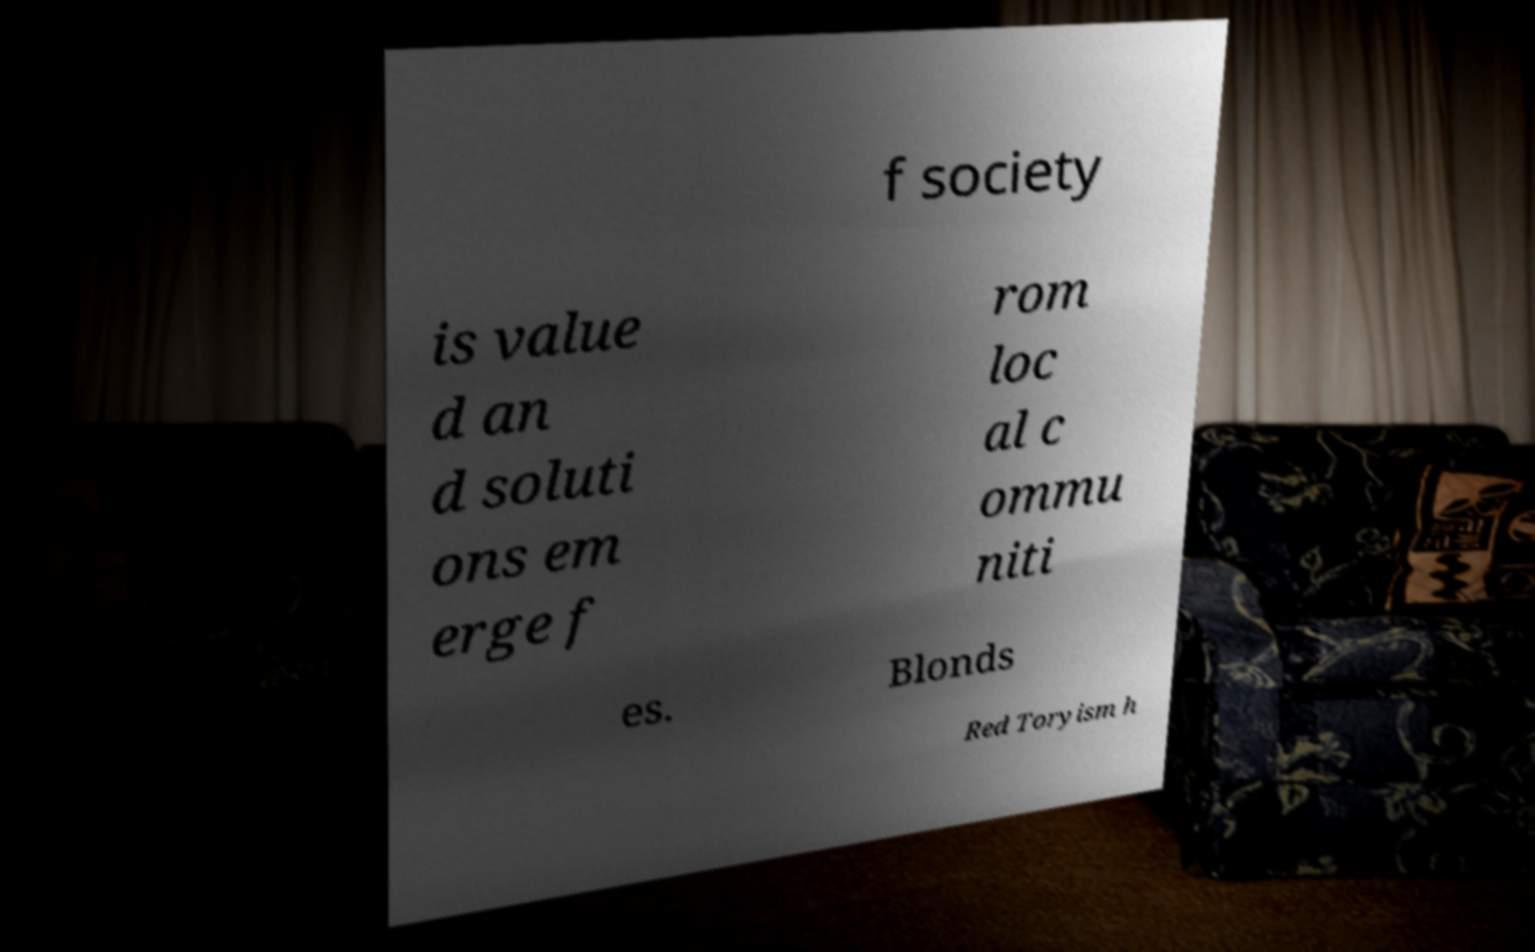Could you extract and type out the text from this image? f society is value d an d soluti ons em erge f rom loc al c ommu niti es. Blonds Red Toryism h 